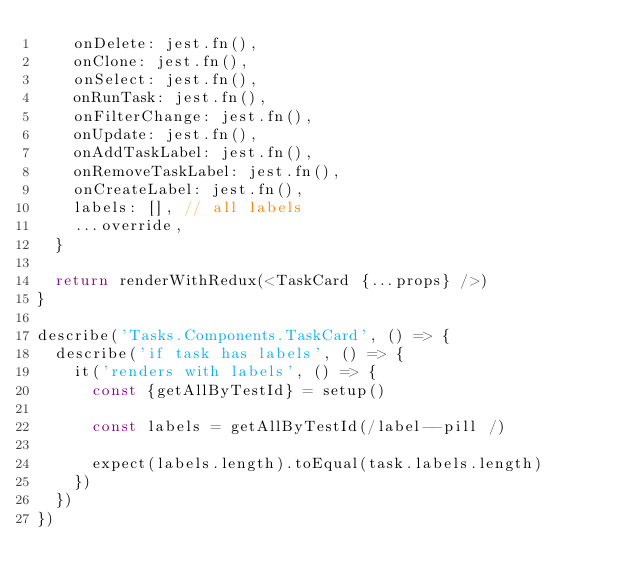Convert code to text. <code><loc_0><loc_0><loc_500><loc_500><_TypeScript_>    onDelete: jest.fn(),
    onClone: jest.fn(),
    onSelect: jest.fn(),
    onRunTask: jest.fn(),
    onFilterChange: jest.fn(),
    onUpdate: jest.fn(),
    onAddTaskLabel: jest.fn(),
    onRemoveTaskLabel: jest.fn(),
    onCreateLabel: jest.fn(),
    labels: [], // all labels
    ...override,
  }

  return renderWithRedux(<TaskCard {...props} />)
}

describe('Tasks.Components.TaskCard', () => {
  describe('if task has labels', () => {
    it('renders with labels', () => {
      const {getAllByTestId} = setup()

      const labels = getAllByTestId(/label--pill /)

      expect(labels.length).toEqual(task.labels.length)
    })
  })
})
</code> 